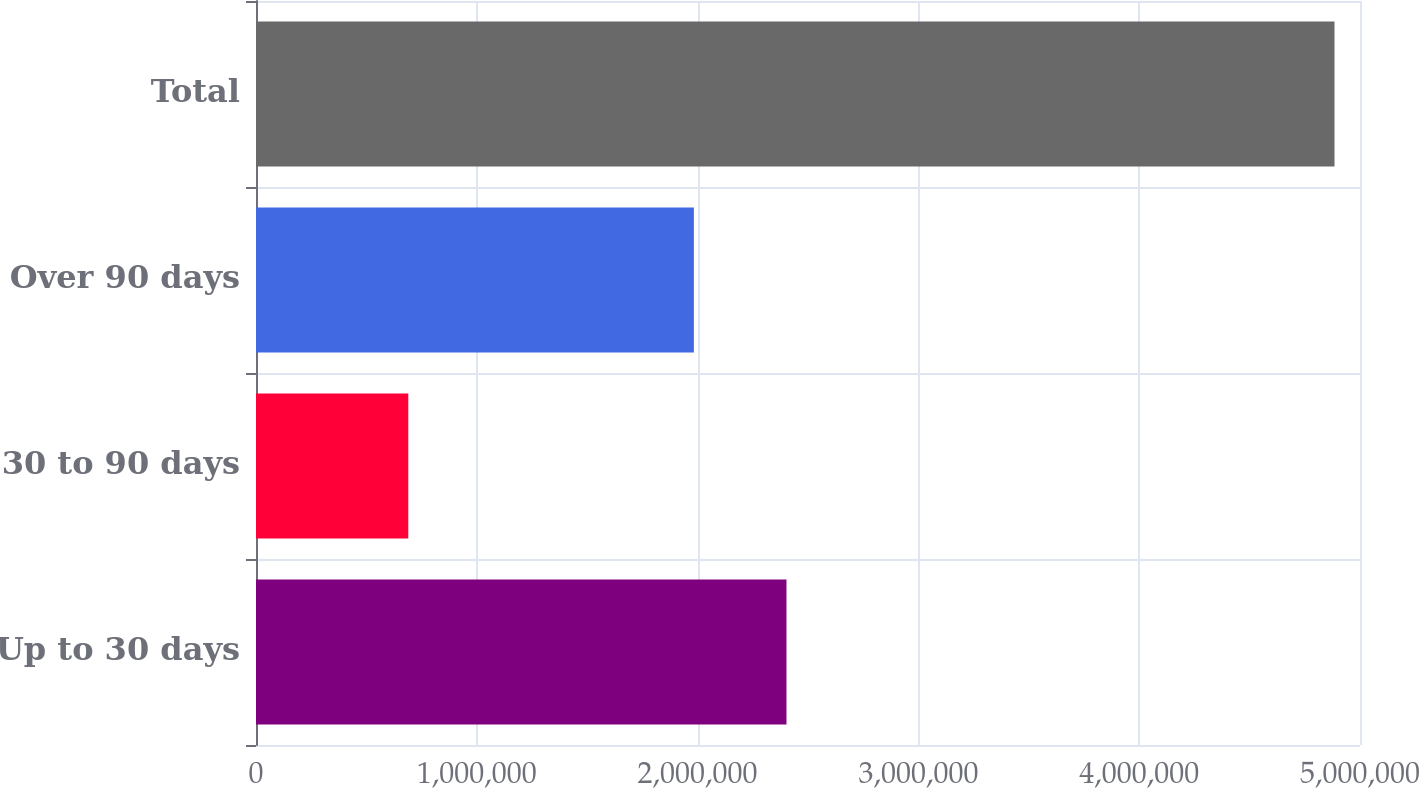Convert chart to OTSL. <chart><loc_0><loc_0><loc_500><loc_500><bar_chart><fcel>Up to 30 days<fcel>30 to 90 days<fcel>Over 90 days<fcel>Total<nl><fcel>2.40256e+06<fcel>689765<fcel>1.98308e+06<fcel>4.88457e+06<nl></chart> 